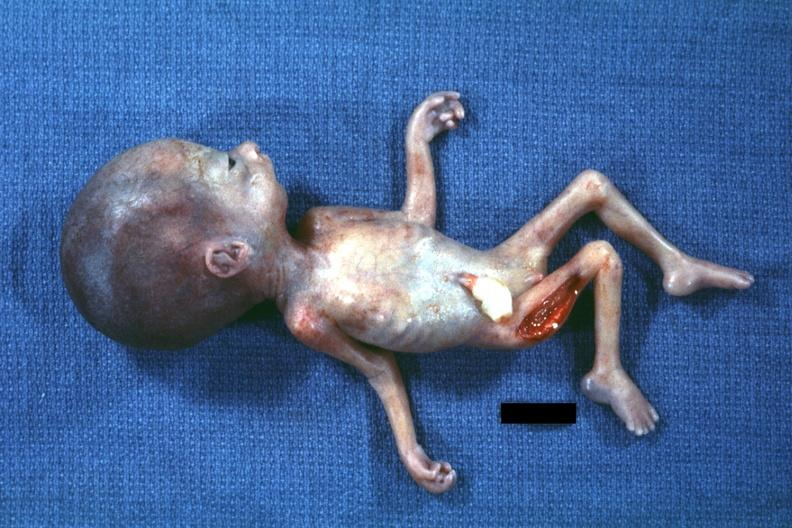what does this image show?
Answer the question using a single word or phrase. Photo of whole body showing head laterally with no chin 